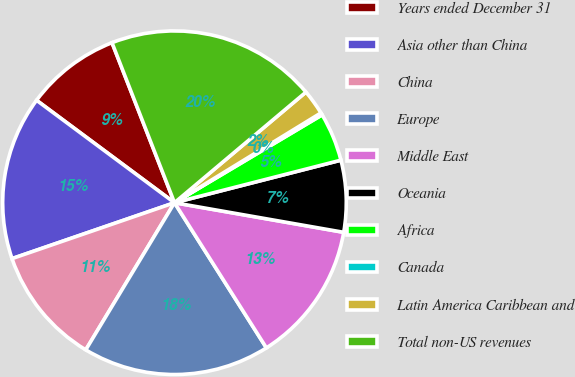Convert chart. <chart><loc_0><loc_0><loc_500><loc_500><pie_chart><fcel>Years ended December 31<fcel>Asia other than China<fcel>China<fcel>Europe<fcel>Middle East<fcel>Oceania<fcel>Africa<fcel>Canada<fcel>Latin America Caribbean and<fcel>Total non-US revenues<nl><fcel>8.91%<fcel>15.44%<fcel>11.09%<fcel>17.62%<fcel>13.26%<fcel>6.74%<fcel>4.56%<fcel>0.21%<fcel>2.38%<fcel>19.79%<nl></chart> 